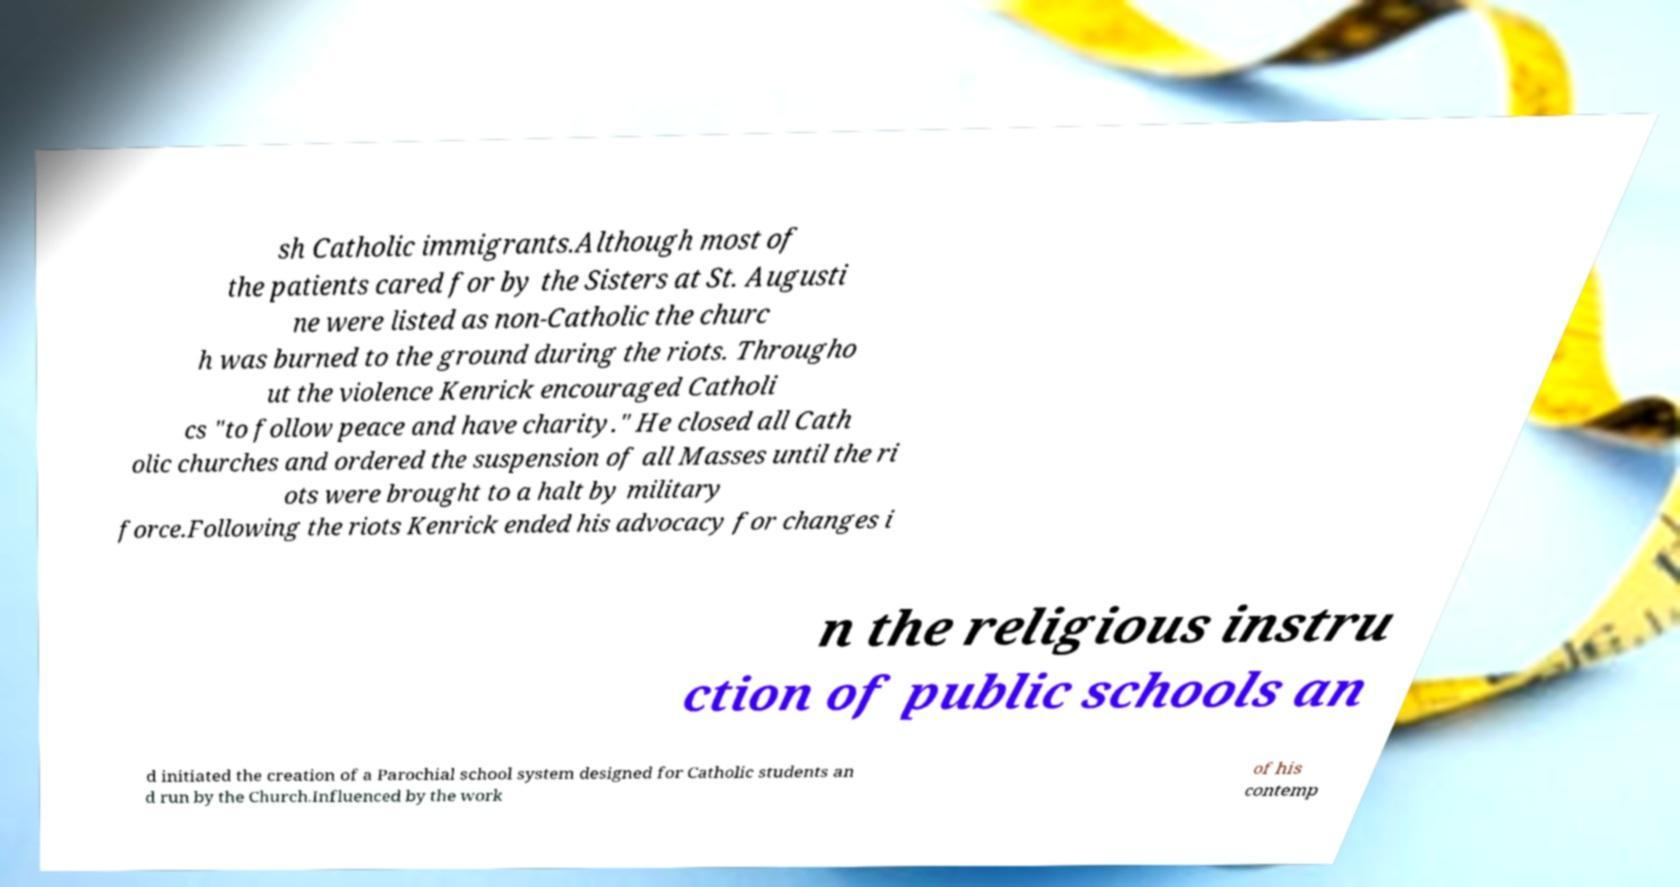Could you assist in decoding the text presented in this image and type it out clearly? sh Catholic immigrants.Although most of the patients cared for by the Sisters at St. Augusti ne were listed as non-Catholic the churc h was burned to the ground during the riots. Througho ut the violence Kenrick encouraged Catholi cs "to follow peace and have charity." He closed all Cath olic churches and ordered the suspension of all Masses until the ri ots were brought to a halt by military force.Following the riots Kenrick ended his advocacy for changes i n the religious instru ction of public schools an d initiated the creation of a Parochial school system designed for Catholic students an d run by the Church.Influenced by the work of his contemp 